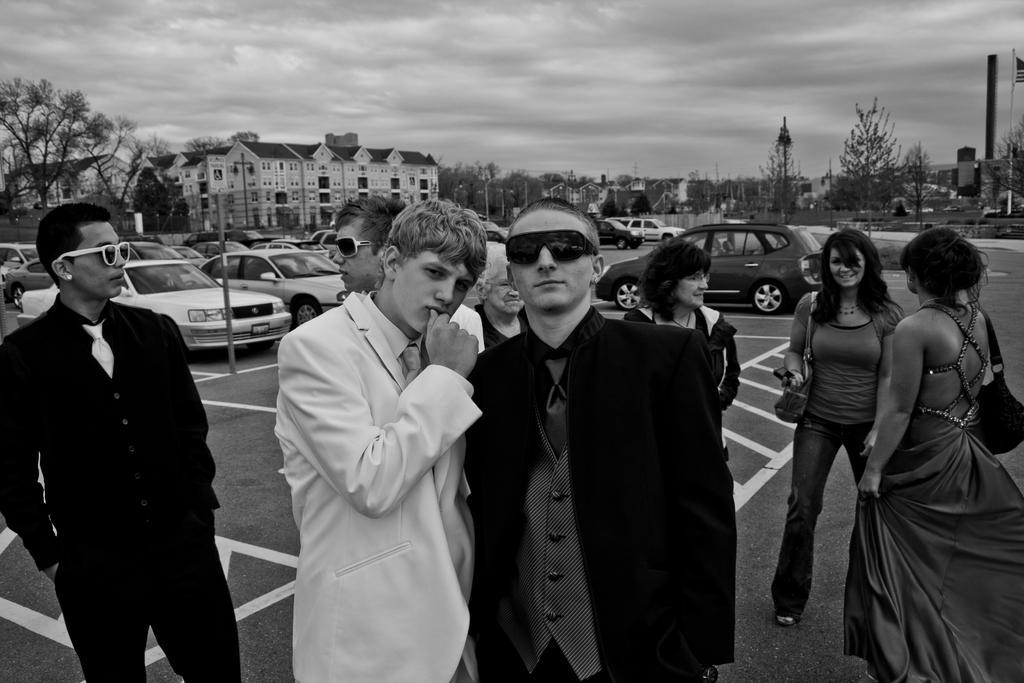Describe this image in one or two sentences. In this image there are many people. Here there are many cars. In the background there are trees, buildings,street lights. Here there is a pole. This is a flag. The sky is cloudy. 